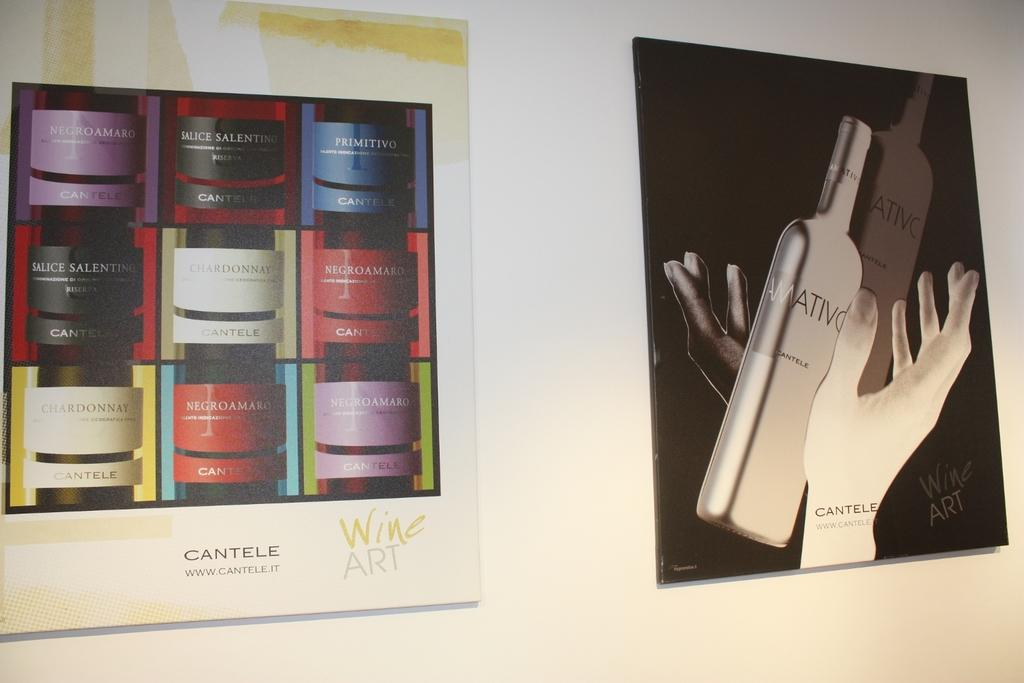<image>
Write a terse but informative summary of the picture. Picture Ads on the wall for Cantele wine art. 